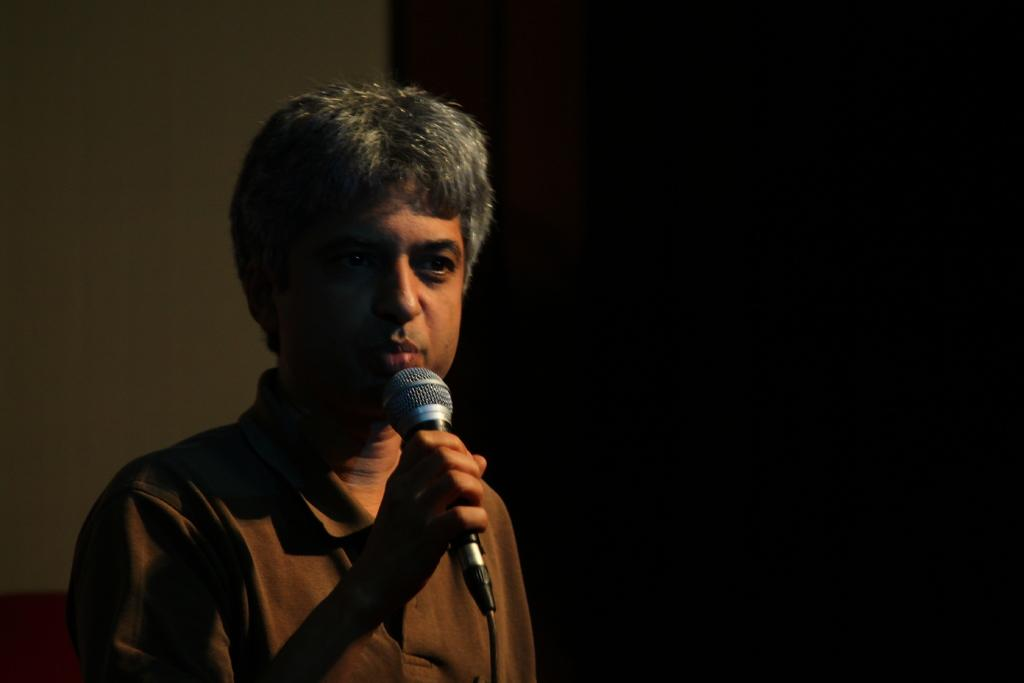What is the main subject of the image? The main subject of the image is a man. What is the man doing in the image? The man is standing and holding a mic. What can be seen in the background of the image? There is a wall and a curtain in the background of the image. What size of chess pieces can be seen on the table in the image? There is no table or chess pieces present in the image. Who is the owner of the mic in the image? The image does not provide information about the ownership of the mic. 